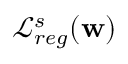<formula> <loc_0><loc_0><loc_500><loc_500>\mathcal { L } _ { r e g } ^ { s } ( w )</formula> 